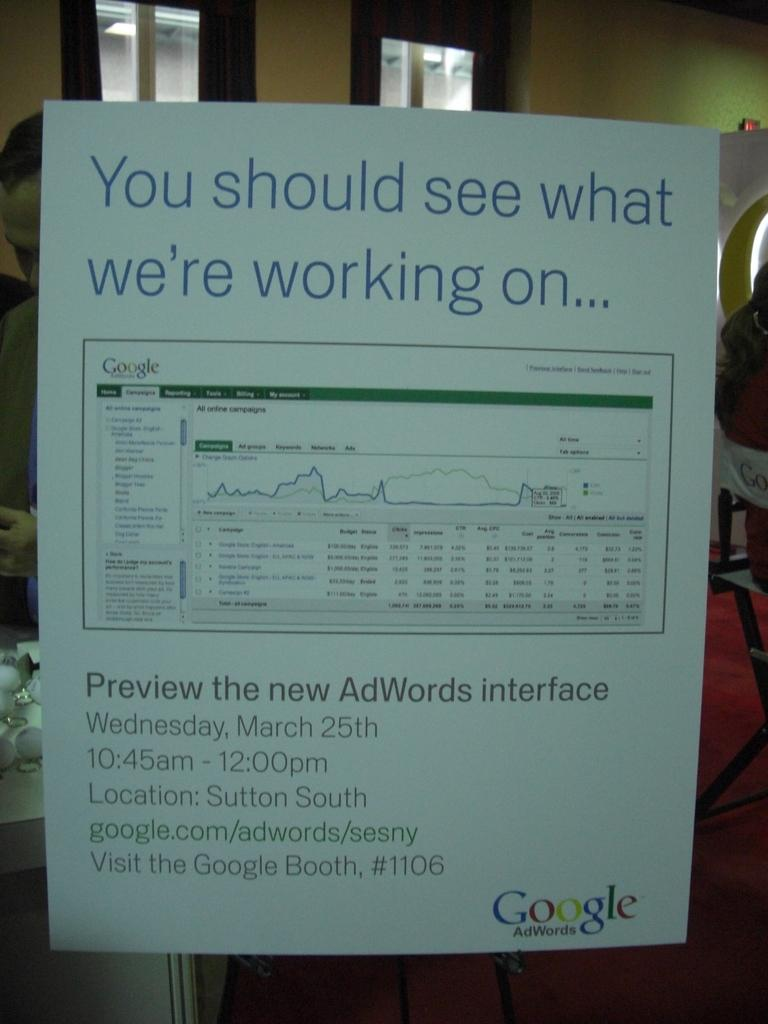Provide a one-sentence caption for the provided image. A paper is posted that has Google written in the right corner. 